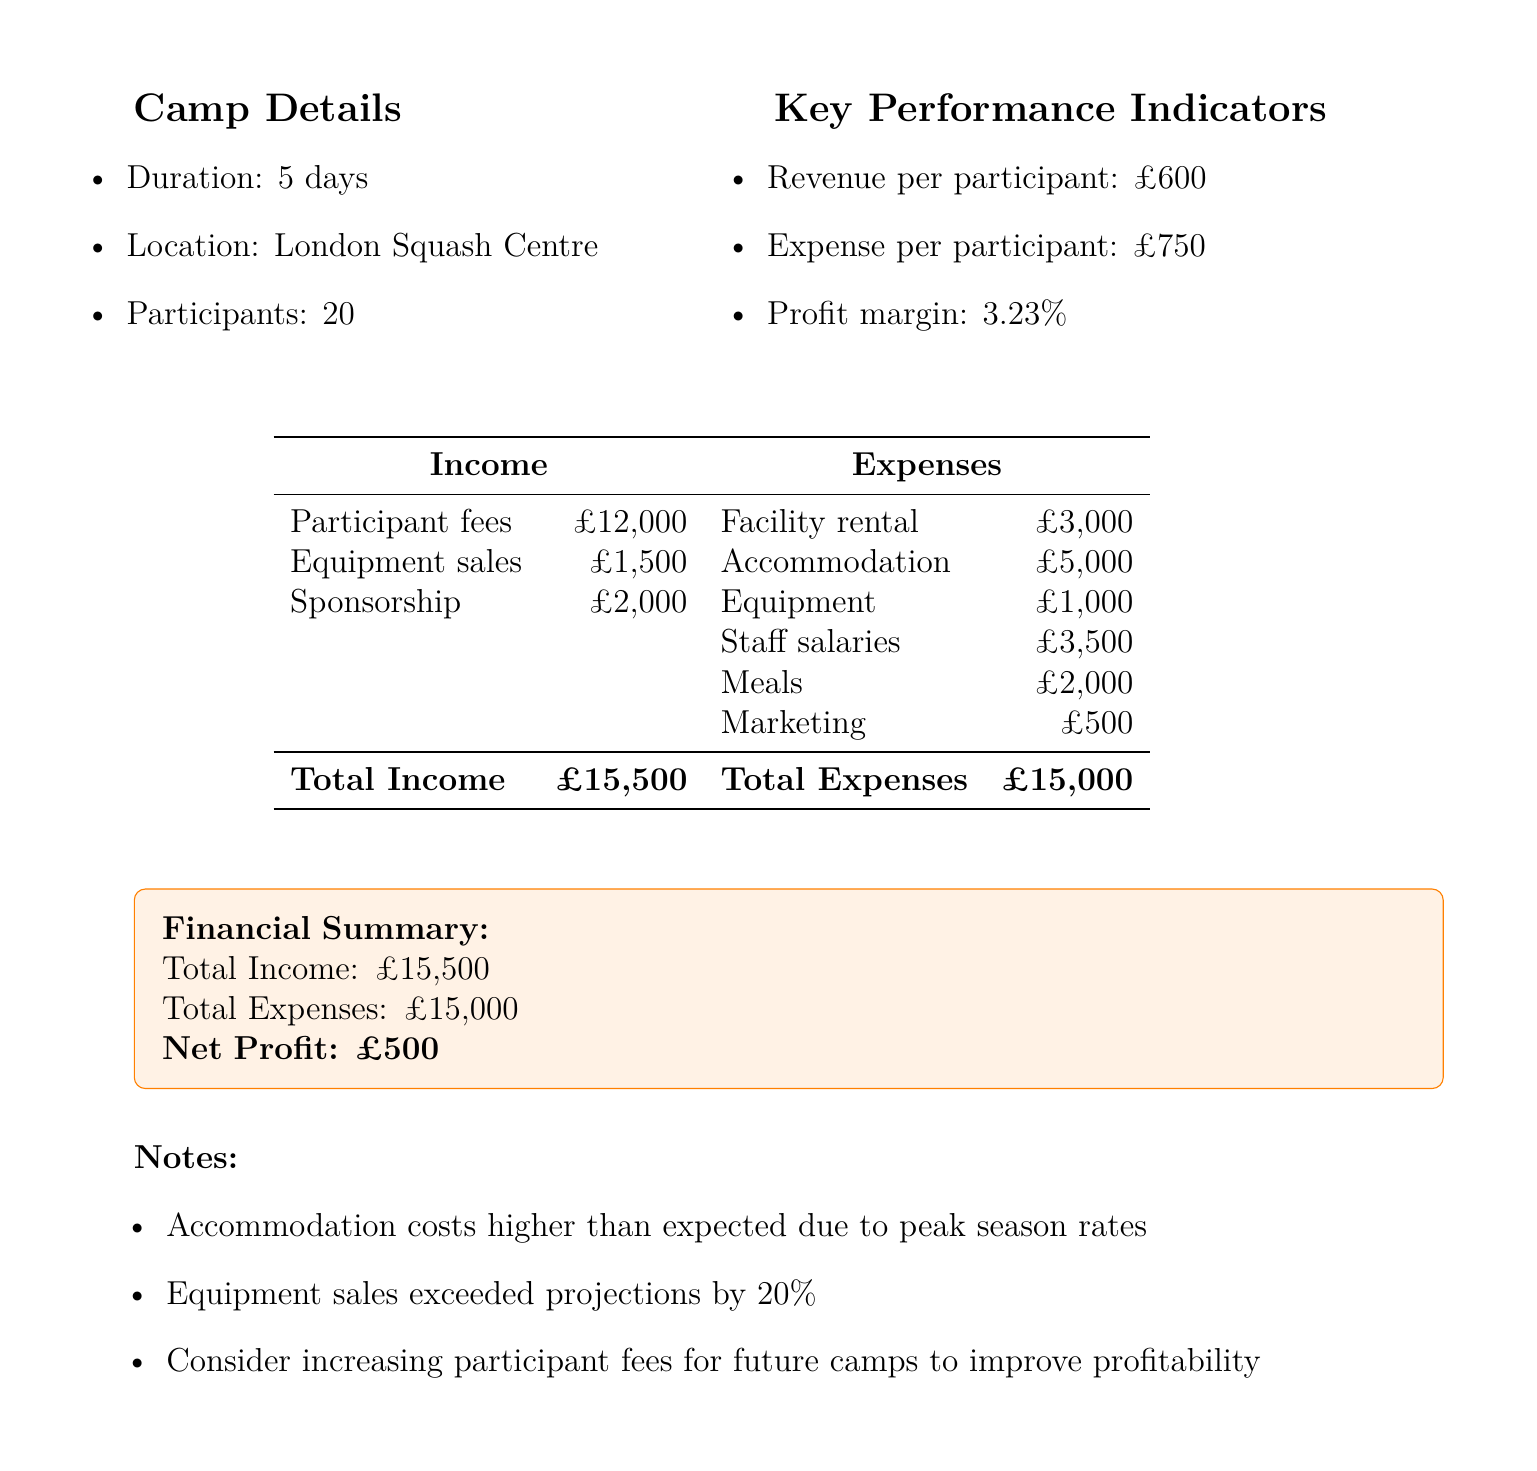What is the total income? The total income is provided in the financial summary, which sums up all income sources.
Answer: £15500 What is the participant fee? The participant fee is listed directly under income in the document.
Answer: £12000 How many participants attended the camp? The document specifies the number of participants in the camp details section.
Answer: 20 What was the accommodation expense? The accommodation expense is explicitly stated in the expenses section.
Answer: £5000 What was the net profit for the camp? The net profit is highlighted in the financial summary of the document.
Answer: £500 What is the expense per participant? The expense per participant is mentioned under key performance indicators and calculated as total expenses divided by participants.
Answer: £750 Why were accommodation costs higher than expected? The document notes specifically states the reasoning for increased accommodation costs.
Answer: Peak season rates Did equipment sales meet projections? The notes section indicates how equipment sales compared to projections.
Answer: Exceeded by 20% What is the profit margin of the camp? The profit margin is explicitly stated in the key performance indicators in the document.
Answer: 3.23% 